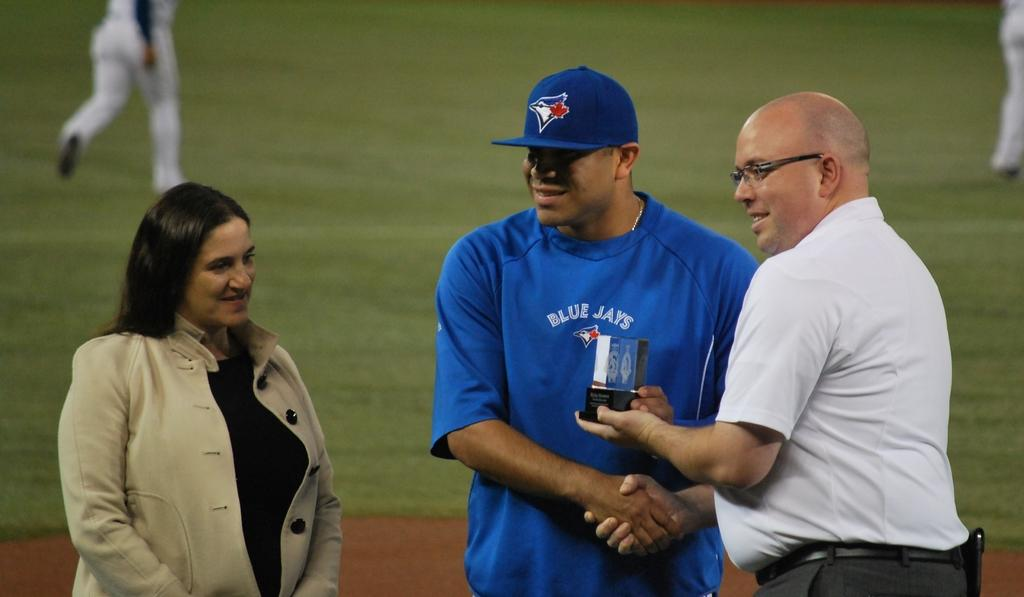<image>
Summarize the visual content of the image. The player in the middle receiving the award is from the Blue Jays. 